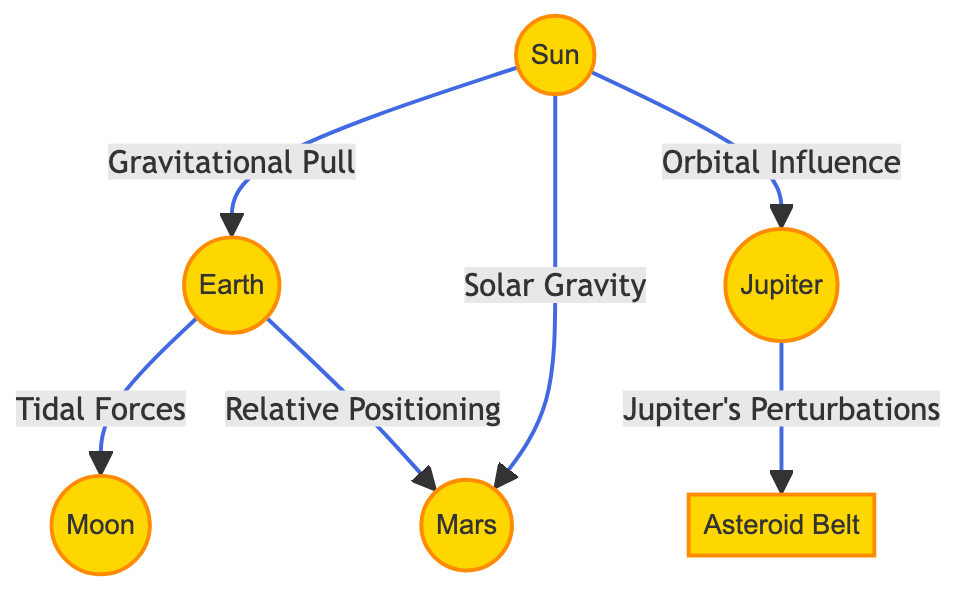What are the celestial bodies represented in the diagram? The diagram features the Sun, Earth, Moon, Mars, Jupiter, and the Asteroid Belt as celestial bodies.
Answer: Sun, Earth, Moon, Mars, Jupiter, Asteroid Belt How many types of interactions are illustrated in the diagram? There are five types of interactions shown: Gravitational Pull, Tidal Forces, Solar Gravity, Orbital Influence, and Jupiter's Perturbations.
Answer: Five What is the relationship between Earth and Moon? The relationship is defined by Tidal Forces, indicating how Earth's gravity affects the Moon.
Answer: Tidal Forces Which celestial body influences Mars through Solar Gravity? The Sun influences Mars through the specified interaction of Solar Gravity.
Answer: Sun Which celestial body is perturbed by Jupiter according to the diagram? The Asteroid Belt is influenced by Jupiter's perturbations, highlighting the interconnection between them.
Answer: Asteroid Belt Explain the interaction between Earth and Mars in the context of their positioning. Earth has a Relative Positioning relationship with Mars, indicating how their spatial arrangement affects their interaction.
Answer: Relative Positioning Which body does Jupiter have an Orbital Influence on? Jupiter has an Orbital Influence on Mars, indicating the gravitational effects it has in relation to Mars' orbit.
Answer: Mars What type of interaction does the Sun have with Earth? The interaction type is Gravitational Pull, which shows the force exerted by the Sun on Earth.
Answer: Gravitational Pull How does the relationship between Jupiter and the Asteroid Belt affect the latter? Jupiter's Perturbations suggest that the gravitational influence from Jupiter impacts the orbits and positions of asteroids in the belt.
Answer: Jupiter's Perturbations 